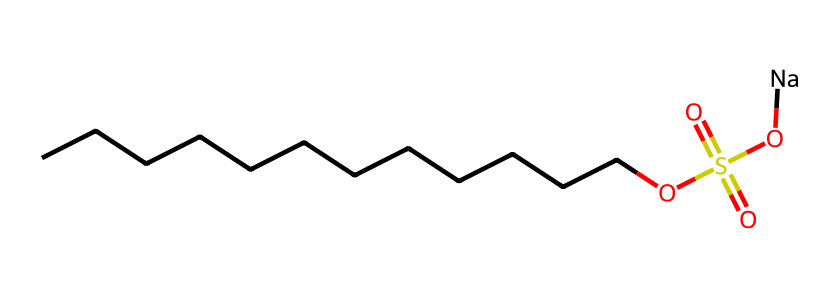How many carbon atoms are present in this surfactant? The SMILES representation shows a long carbon chain (CCCCCCCCCCCC), indicating there are a total of 12 carbon atoms in the structure.
Answer: 12 What is the functional group present in this chemical? The presence of the -OS(=O)(=O)O fragment indicates that there is a sulfonate functional group in this surfactant, making it hydrophilic.
Answer: sulfonate Is this surfactant ionic or non-ionic? The presence of the sodium ion (Na) implies that this surfactant is ionic, due to its ability to dissociate in solution.
Answer: ionic What type of surfactant is described by this structure? Based on the SMILES, it is a anionic surfactant because it has a negative charge from the sulfonate group that interacts well with water.
Answer: anionic What role do the carbon chain and sulfonate group play in this surfactant's properties? The long carbon chain provides hydrophobic properties, while the sulfonate group provides hydrophilic properties, allowing it to act as a surfactant that can lower the surface tension of water.
Answer: surfactant properties How many oxygen atoms are in this chemical? The sulfonate group (-OS(=O)(=O)O) contains four oxygen atoms, which are counted directly from the structural representation.
Answer: 4 